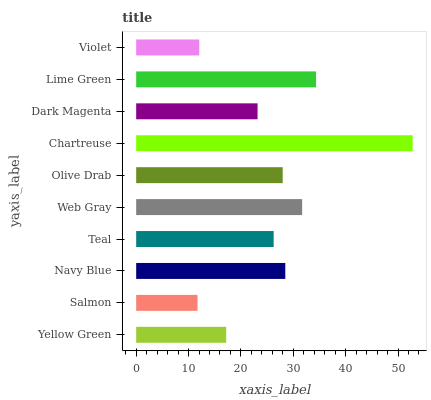Is Salmon the minimum?
Answer yes or no. Yes. Is Chartreuse the maximum?
Answer yes or no. Yes. Is Navy Blue the minimum?
Answer yes or no. No. Is Navy Blue the maximum?
Answer yes or no. No. Is Navy Blue greater than Salmon?
Answer yes or no. Yes. Is Salmon less than Navy Blue?
Answer yes or no. Yes. Is Salmon greater than Navy Blue?
Answer yes or no. No. Is Navy Blue less than Salmon?
Answer yes or no. No. Is Olive Drab the high median?
Answer yes or no. Yes. Is Teal the low median?
Answer yes or no. Yes. Is Lime Green the high median?
Answer yes or no. No. Is Lime Green the low median?
Answer yes or no. No. 